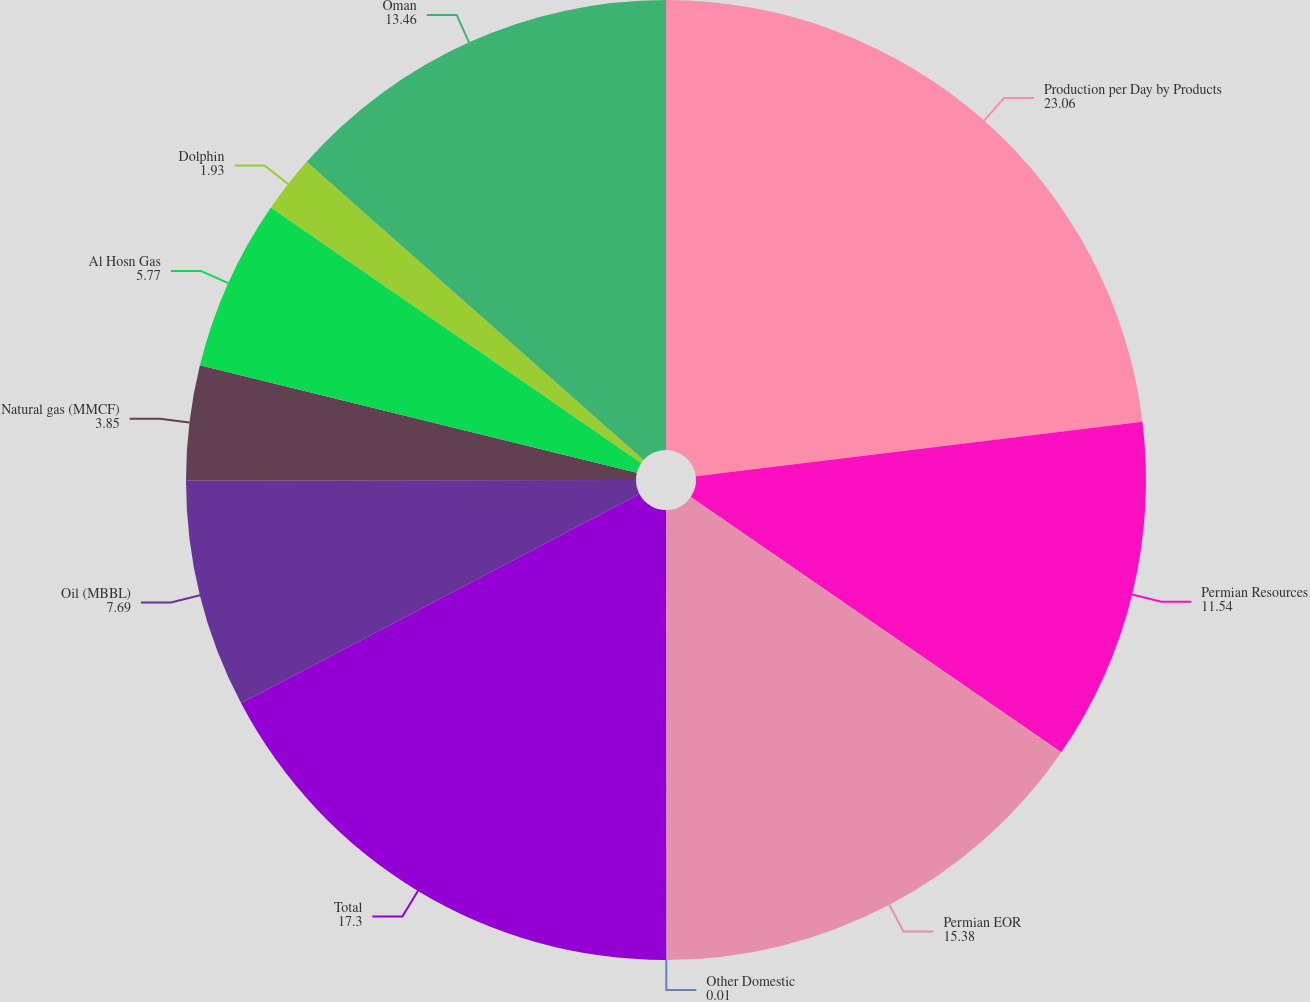<chart> <loc_0><loc_0><loc_500><loc_500><pie_chart><fcel>Production per Day by Products<fcel>Permian Resources<fcel>Permian EOR<fcel>Other Domestic<fcel>Total<fcel>Oil (MBBL)<fcel>Natural gas (MMCF)<fcel>Al Hosn Gas<fcel>Dolphin<fcel>Oman<nl><fcel>23.06%<fcel>11.54%<fcel>15.38%<fcel>0.01%<fcel>17.3%<fcel>7.69%<fcel>3.85%<fcel>5.77%<fcel>1.93%<fcel>13.46%<nl></chart> 